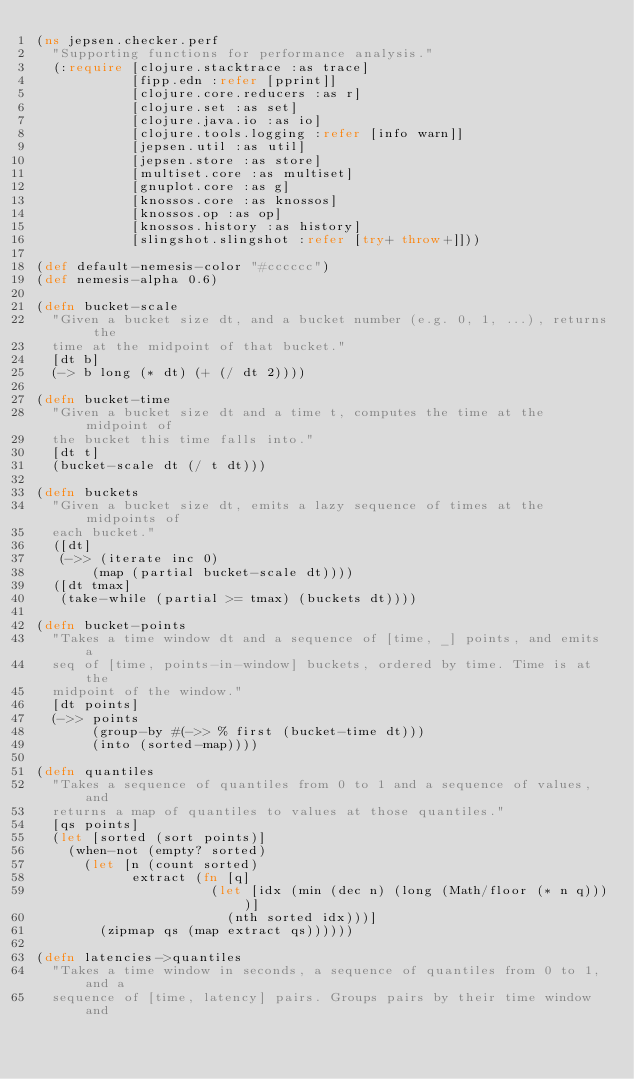Convert code to text. <code><loc_0><loc_0><loc_500><loc_500><_Clojure_>(ns jepsen.checker.perf
  "Supporting functions for performance analysis."
  (:require [clojure.stacktrace :as trace]
            [fipp.edn :refer [pprint]]
            [clojure.core.reducers :as r]
            [clojure.set :as set]
            [clojure.java.io :as io]
            [clojure.tools.logging :refer [info warn]]
            [jepsen.util :as util]
            [jepsen.store :as store]
            [multiset.core :as multiset]
            [gnuplot.core :as g]
            [knossos.core :as knossos]
            [knossos.op :as op]
            [knossos.history :as history]
            [slingshot.slingshot :refer [try+ throw+]]))

(def default-nemesis-color "#cccccc")
(def nemesis-alpha 0.6)

(defn bucket-scale
  "Given a bucket size dt, and a bucket number (e.g. 0, 1, ...), returns the
  time at the midpoint of that bucket."
  [dt b]
  (-> b long (* dt) (+ (/ dt 2))))

(defn bucket-time
  "Given a bucket size dt and a time t, computes the time at the midpoint of
  the bucket this time falls into."
  [dt t]
  (bucket-scale dt (/ t dt)))

(defn buckets
  "Given a bucket size dt, emits a lazy sequence of times at the midpoints of
  each bucket."
  ([dt]
   (->> (iterate inc 0)
       (map (partial bucket-scale dt))))
  ([dt tmax]
   (take-while (partial >= tmax) (buckets dt))))

(defn bucket-points
  "Takes a time window dt and a sequence of [time, _] points, and emits a
  seq of [time, points-in-window] buckets, ordered by time. Time is at the
  midpoint of the window."
  [dt points]
  (->> points
       (group-by #(->> % first (bucket-time dt)))
       (into (sorted-map))))

(defn quantiles
  "Takes a sequence of quantiles from 0 to 1 and a sequence of values, and
  returns a map of quantiles to values at those quantiles."
  [qs points]
  (let [sorted (sort points)]
    (when-not (empty? sorted)
      (let [n (count sorted)
            extract (fn [q]
                      (let [idx (min (dec n) (long (Math/floor (* n q))))]
                        (nth sorted idx)))]
        (zipmap qs (map extract qs))))))

(defn latencies->quantiles
  "Takes a time window in seconds, a sequence of quantiles from 0 to 1, and a
  sequence of [time, latency] pairs. Groups pairs by their time window and</code> 